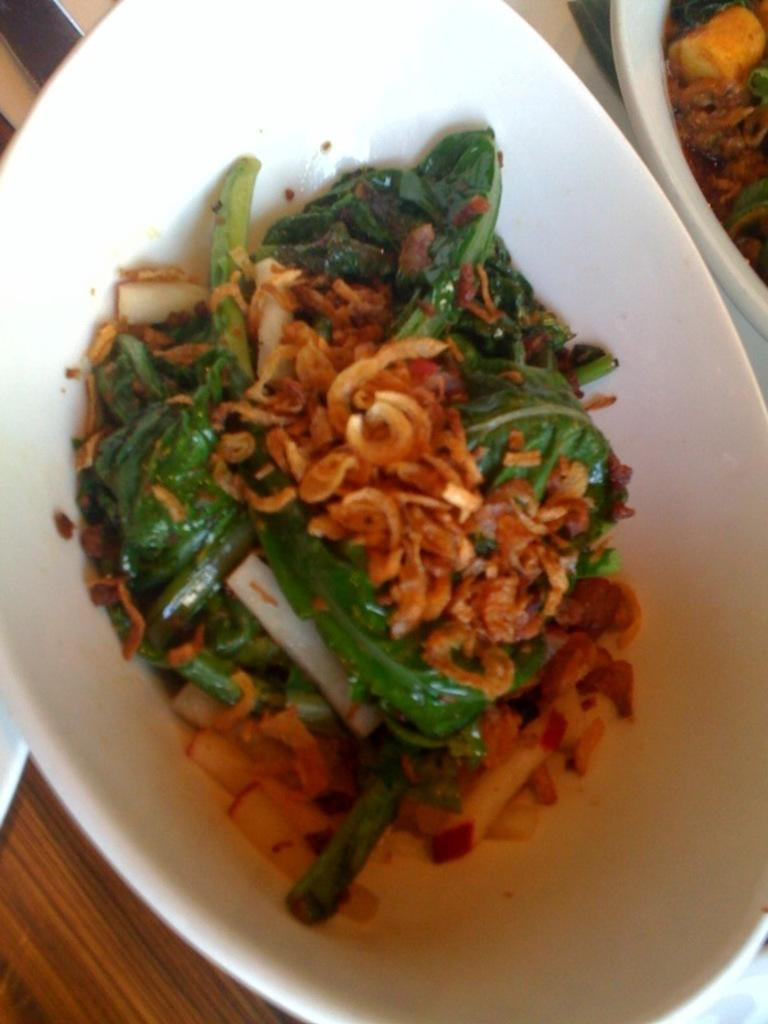What color is the bowl that is visible in the image? The bowl in the image is white. What is inside the bowl? There is food in the bowl. Can you see a person touching the bowl in the image? There is no person visible in the image, and therefore no one is touching the bowl. How many beds are present in the image? There are no beds present in the image; it only features a white bowl with food in it. 